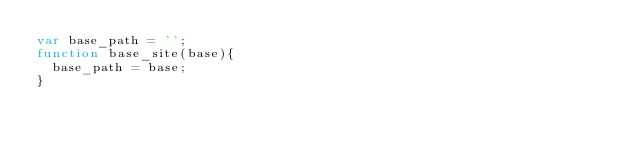Convert code to text. <code><loc_0><loc_0><loc_500><loc_500><_JavaScript_>var base_path = '';
function base_site(base){
  base_path = base; 
}</code> 